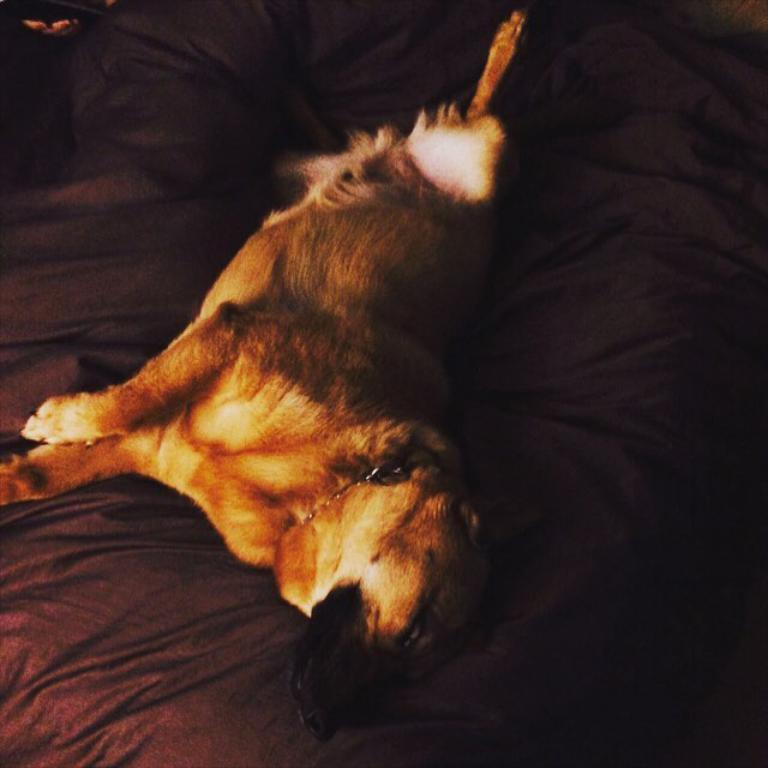What is the overall lighting condition of the image? The image is slightly dark. What animal can be seen in the image? There is a dog in the image. Where is the dog located in the image? The dog is lying on a bed. What type of toy can be seen in the image? There is no toy present in the image; it features a dog lying on a bed in a slightly dark setting. 